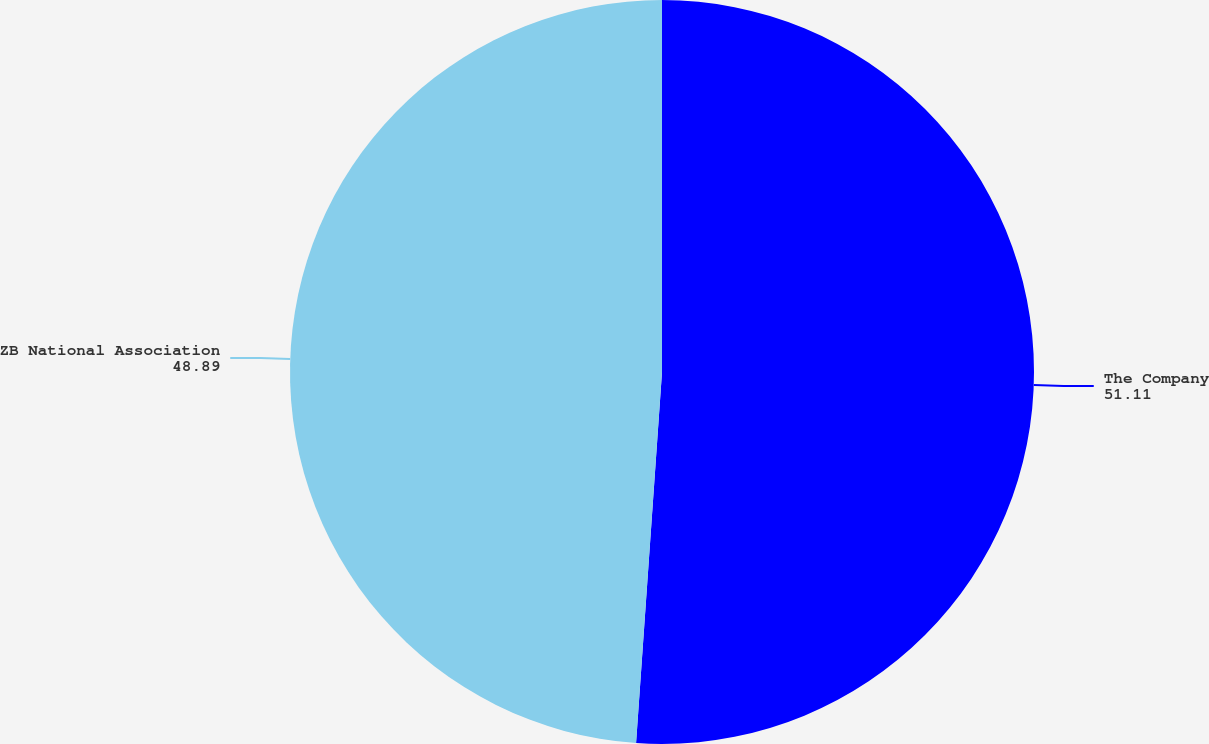<chart> <loc_0><loc_0><loc_500><loc_500><pie_chart><fcel>The Company<fcel>ZB National Association<nl><fcel>51.11%<fcel>48.89%<nl></chart> 